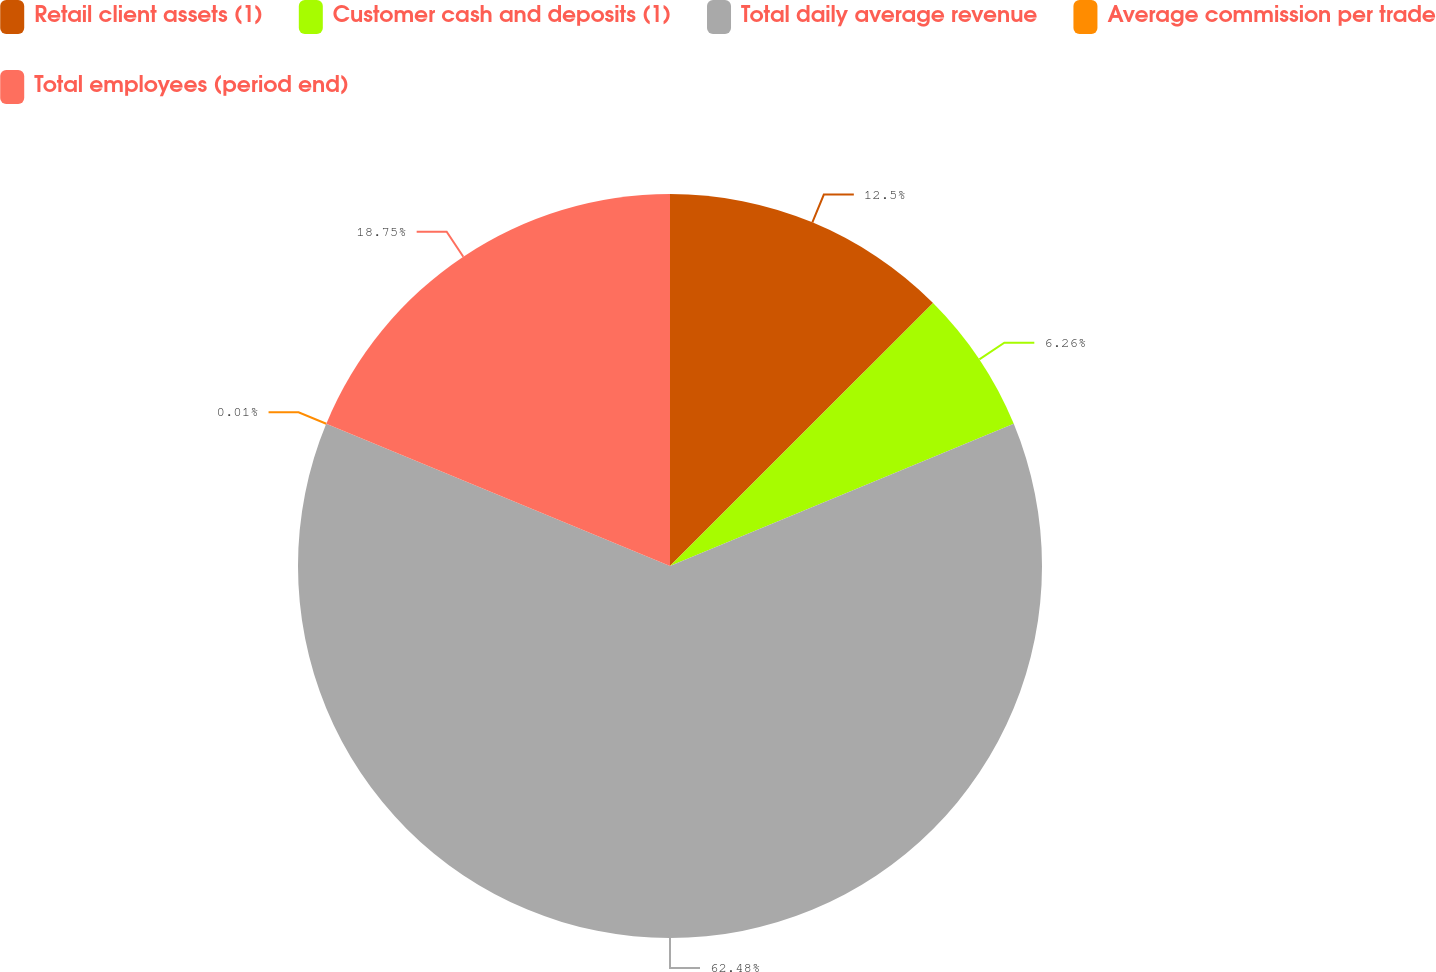Convert chart to OTSL. <chart><loc_0><loc_0><loc_500><loc_500><pie_chart><fcel>Retail client assets (1)<fcel>Customer cash and deposits (1)<fcel>Total daily average revenue<fcel>Average commission per trade<fcel>Total employees (period end)<nl><fcel>12.5%<fcel>6.26%<fcel>62.48%<fcel>0.01%<fcel>18.75%<nl></chart> 